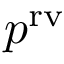<formula> <loc_0><loc_0><loc_500><loc_500>p ^ { r v }</formula> 